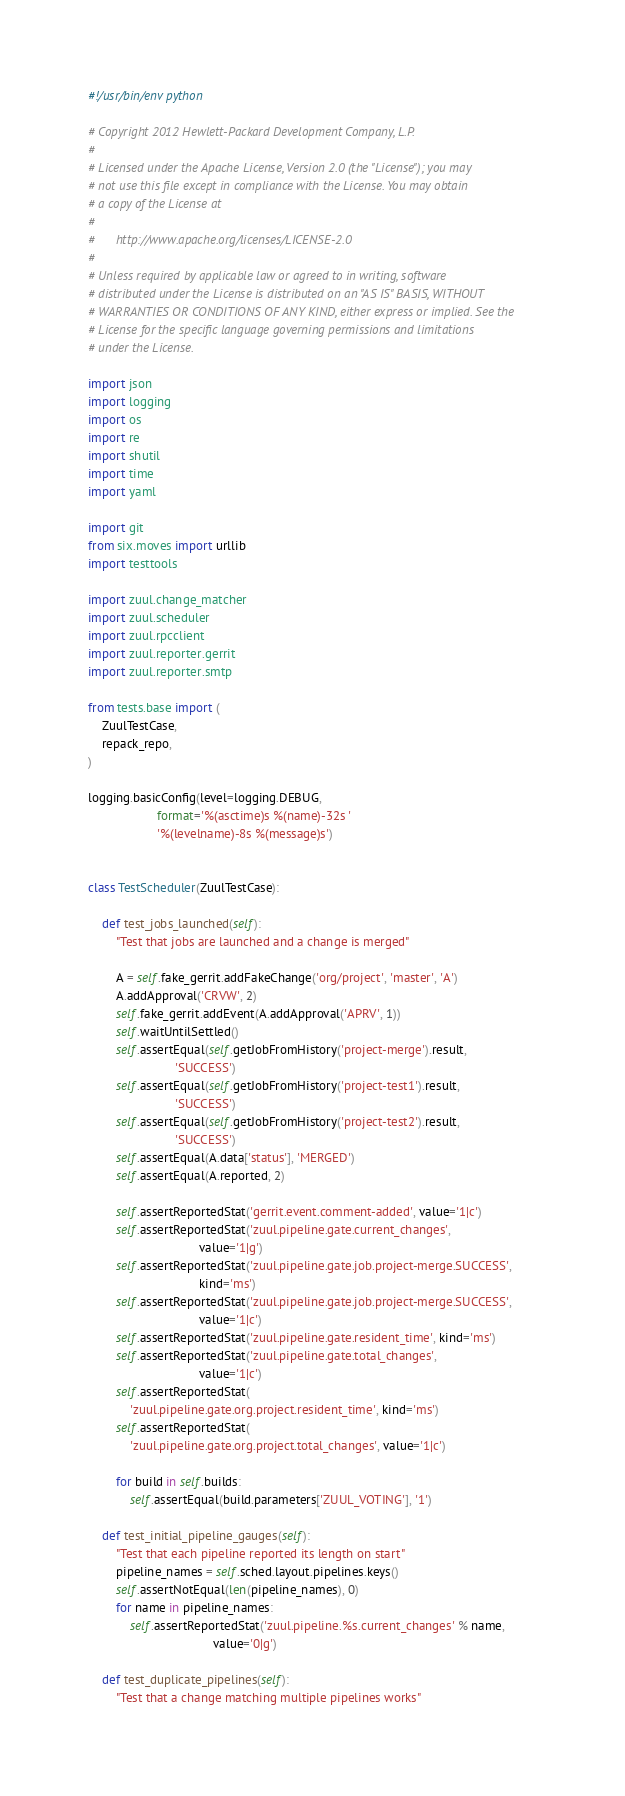<code> <loc_0><loc_0><loc_500><loc_500><_Python_>#!/usr/bin/env python

# Copyright 2012 Hewlett-Packard Development Company, L.P.
#
# Licensed under the Apache License, Version 2.0 (the "License"); you may
# not use this file except in compliance with the License. You may obtain
# a copy of the License at
#
#      http://www.apache.org/licenses/LICENSE-2.0
#
# Unless required by applicable law or agreed to in writing, software
# distributed under the License is distributed on an "AS IS" BASIS, WITHOUT
# WARRANTIES OR CONDITIONS OF ANY KIND, either express or implied. See the
# License for the specific language governing permissions and limitations
# under the License.

import json
import logging
import os
import re
import shutil
import time
import yaml

import git
from six.moves import urllib
import testtools

import zuul.change_matcher
import zuul.scheduler
import zuul.rpcclient
import zuul.reporter.gerrit
import zuul.reporter.smtp

from tests.base import (
    ZuulTestCase,
    repack_repo,
)

logging.basicConfig(level=logging.DEBUG,
                    format='%(asctime)s %(name)-32s '
                    '%(levelname)-8s %(message)s')


class TestScheduler(ZuulTestCase):

    def test_jobs_launched(self):
        "Test that jobs are launched and a change is merged"

        A = self.fake_gerrit.addFakeChange('org/project', 'master', 'A')
        A.addApproval('CRVW', 2)
        self.fake_gerrit.addEvent(A.addApproval('APRV', 1))
        self.waitUntilSettled()
        self.assertEqual(self.getJobFromHistory('project-merge').result,
                         'SUCCESS')
        self.assertEqual(self.getJobFromHistory('project-test1').result,
                         'SUCCESS')
        self.assertEqual(self.getJobFromHistory('project-test2').result,
                         'SUCCESS')
        self.assertEqual(A.data['status'], 'MERGED')
        self.assertEqual(A.reported, 2)

        self.assertReportedStat('gerrit.event.comment-added', value='1|c')
        self.assertReportedStat('zuul.pipeline.gate.current_changes',
                                value='1|g')
        self.assertReportedStat('zuul.pipeline.gate.job.project-merge.SUCCESS',
                                kind='ms')
        self.assertReportedStat('zuul.pipeline.gate.job.project-merge.SUCCESS',
                                value='1|c')
        self.assertReportedStat('zuul.pipeline.gate.resident_time', kind='ms')
        self.assertReportedStat('zuul.pipeline.gate.total_changes',
                                value='1|c')
        self.assertReportedStat(
            'zuul.pipeline.gate.org.project.resident_time', kind='ms')
        self.assertReportedStat(
            'zuul.pipeline.gate.org.project.total_changes', value='1|c')

        for build in self.builds:
            self.assertEqual(build.parameters['ZUUL_VOTING'], '1')

    def test_initial_pipeline_gauges(self):
        "Test that each pipeline reported its length on start"
        pipeline_names = self.sched.layout.pipelines.keys()
        self.assertNotEqual(len(pipeline_names), 0)
        for name in pipeline_names:
            self.assertReportedStat('zuul.pipeline.%s.current_changes' % name,
                                    value='0|g')

    def test_duplicate_pipelines(self):
        "Test that a change matching multiple pipelines works"
</code> 